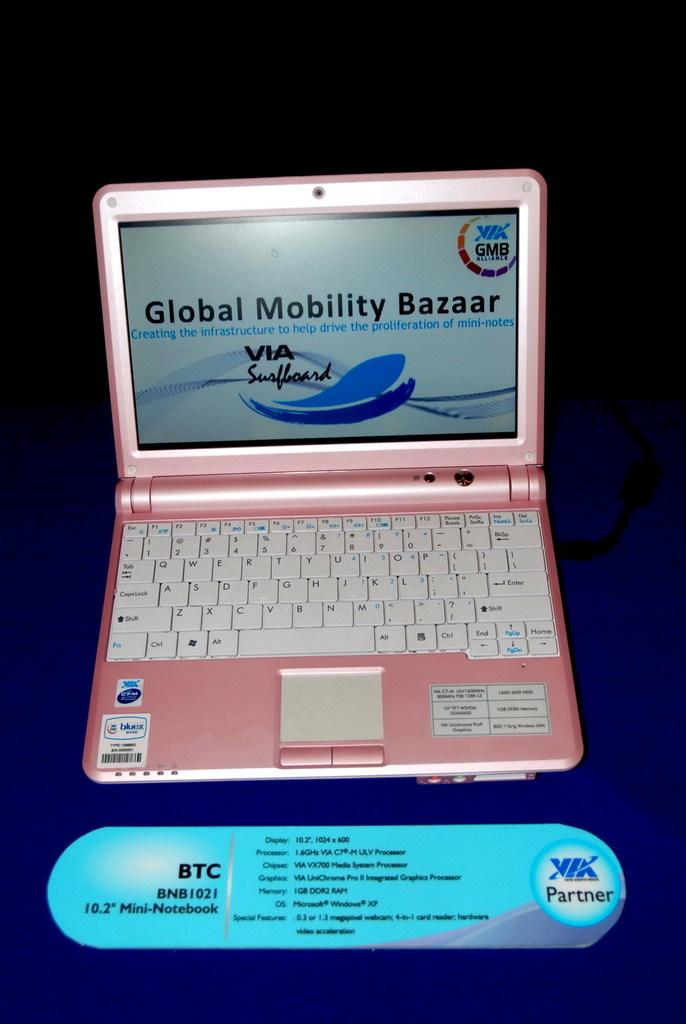<image>
Write a terse but informative summary of the picture. A laptop displays a Global Mobility Bazaar web page. 